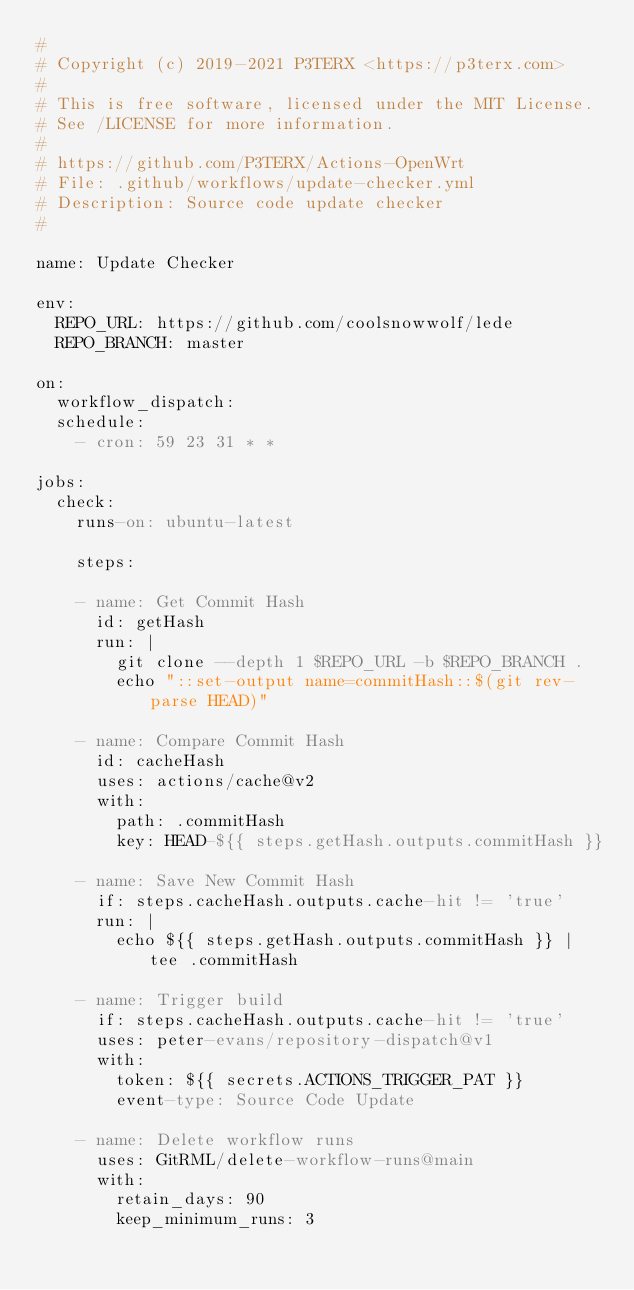<code> <loc_0><loc_0><loc_500><loc_500><_YAML_>#
# Copyright (c) 2019-2021 P3TERX <https://p3terx.com>
#
# This is free software, licensed under the MIT License.
# See /LICENSE for more information.
#
# https://github.com/P3TERX/Actions-OpenWrt
# File: .github/workflows/update-checker.yml
# Description: Source code update checker
#

name: Update Checker

env:
  REPO_URL: https://github.com/coolsnowwolf/lede
  REPO_BRANCH: master

on:
  workflow_dispatch:
  schedule:
    - cron: 59 23 31 * *

jobs:
  check:
    runs-on: ubuntu-latest

    steps:

    - name: Get Commit Hash
      id: getHash
      run: |
        git clone --depth 1 $REPO_URL -b $REPO_BRANCH .
        echo "::set-output name=commitHash::$(git rev-parse HEAD)"

    - name: Compare Commit Hash
      id: cacheHash
      uses: actions/cache@v2
      with:
        path: .commitHash
        key: HEAD-${{ steps.getHash.outputs.commitHash }}

    - name: Save New Commit Hash
      if: steps.cacheHash.outputs.cache-hit != 'true'
      run: |
        echo ${{ steps.getHash.outputs.commitHash }} | tee .commitHash

    - name: Trigger build
      if: steps.cacheHash.outputs.cache-hit != 'true'
      uses: peter-evans/repository-dispatch@v1
      with:
        token: ${{ secrets.ACTIONS_TRIGGER_PAT }}
        event-type: Source Code Update

    - name: Delete workflow runs
      uses: GitRML/delete-workflow-runs@main
      with:
        retain_days: 90
        keep_minimum_runs: 3
</code> 